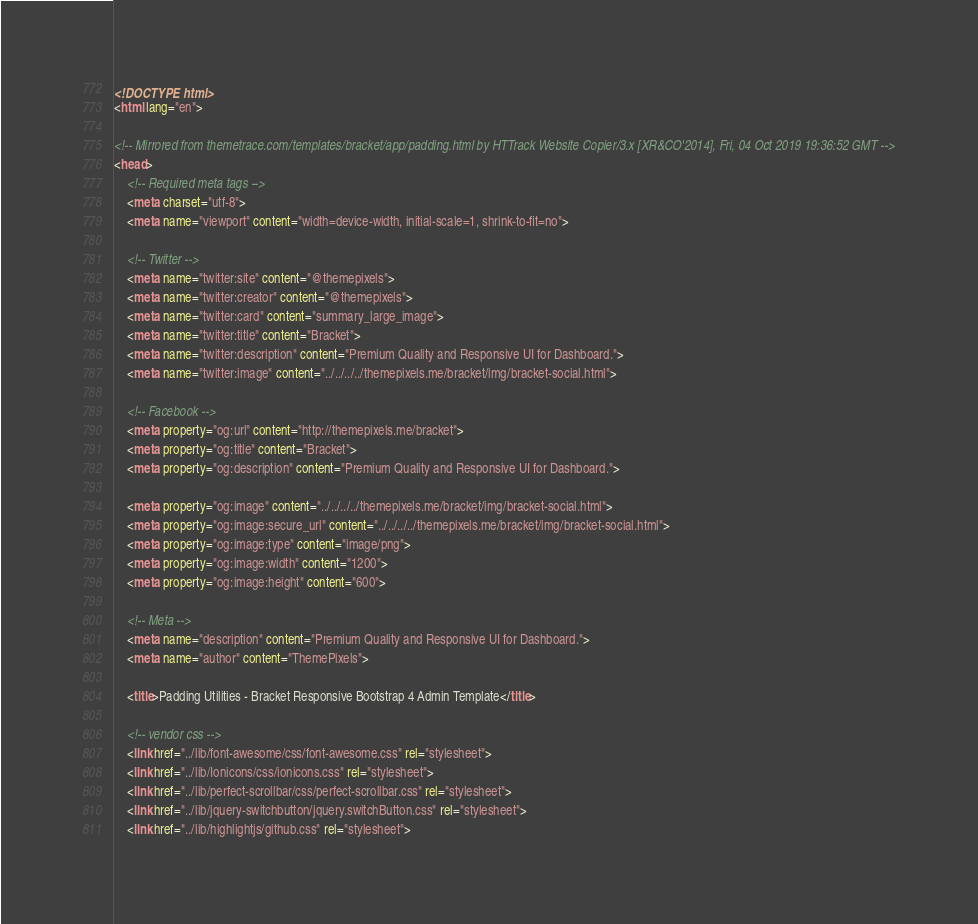Convert code to text. <code><loc_0><loc_0><loc_500><loc_500><_HTML_><!DOCTYPE html>
<html lang="en">
  
<!-- Mirrored from themetrace.com/templates/bracket/app/padding.html by HTTrack Website Copier/3.x [XR&CO'2014], Fri, 04 Oct 2019 19:36:52 GMT -->
<head>
    <!-- Required meta tags -->
    <meta charset="utf-8">
    <meta name="viewport" content="width=device-width, initial-scale=1, shrink-to-fit=no">

    <!-- Twitter -->
    <meta name="twitter:site" content="@themepixels">
    <meta name="twitter:creator" content="@themepixels">
    <meta name="twitter:card" content="summary_large_image">
    <meta name="twitter:title" content="Bracket">
    <meta name="twitter:description" content="Premium Quality and Responsive UI for Dashboard.">
    <meta name="twitter:image" content="../../../../themepixels.me/bracket/img/bracket-social.html">

    <!-- Facebook -->
    <meta property="og:url" content="http://themepixels.me/bracket">
    <meta property="og:title" content="Bracket">
    <meta property="og:description" content="Premium Quality and Responsive UI for Dashboard.">

    <meta property="og:image" content="../../../../themepixels.me/bracket/img/bracket-social.html">
    <meta property="og:image:secure_url" content="../../../../themepixels.me/bracket/img/bracket-social.html">
    <meta property="og:image:type" content="image/png">
    <meta property="og:image:width" content="1200">
    <meta property="og:image:height" content="600">

    <!-- Meta -->
    <meta name="description" content="Premium Quality and Responsive UI for Dashboard.">
    <meta name="author" content="ThemePixels">

    <title>Padding Utilities - Bracket Responsive Bootstrap 4 Admin Template</title>

    <!-- vendor css -->
    <link href="../lib/font-awesome/css/font-awesome.css" rel="stylesheet">
    <link href="../lib/Ionicons/css/ionicons.css" rel="stylesheet">
    <link href="../lib/perfect-scrollbar/css/perfect-scrollbar.css" rel="stylesheet">
    <link href="../lib/jquery-switchbutton/jquery.switchButton.css" rel="stylesheet">
    <link href="../lib/highlightjs/github.css" rel="stylesheet"></code> 